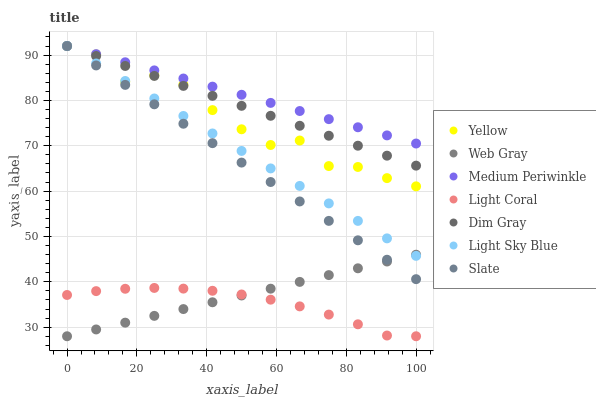Does Light Coral have the minimum area under the curve?
Answer yes or no. Yes. Does Medium Periwinkle have the maximum area under the curve?
Answer yes or no. Yes. Does Slate have the minimum area under the curve?
Answer yes or no. No. Does Slate have the maximum area under the curve?
Answer yes or no. No. Is Web Gray the smoothest?
Answer yes or no. Yes. Is Yellow the roughest?
Answer yes or no. Yes. Is Slate the smoothest?
Answer yes or no. No. Is Slate the roughest?
Answer yes or no. No. Does Light Coral have the lowest value?
Answer yes or no. Yes. Does Slate have the lowest value?
Answer yes or no. No. Does Light Sky Blue have the highest value?
Answer yes or no. Yes. Does Light Coral have the highest value?
Answer yes or no. No. Is Light Coral less than Medium Periwinkle?
Answer yes or no. Yes. Is Dim Gray greater than Light Coral?
Answer yes or no. Yes. Does Web Gray intersect Light Sky Blue?
Answer yes or no. Yes. Is Web Gray less than Light Sky Blue?
Answer yes or no. No. Is Web Gray greater than Light Sky Blue?
Answer yes or no. No. Does Light Coral intersect Medium Periwinkle?
Answer yes or no. No. 